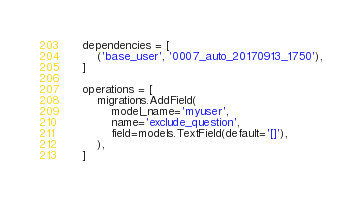<code> <loc_0><loc_0><loc_500><loc_500><_Python_>
    dependencies = [
        ('base_user', '0007_auto_20170913_1750'),
    ]

    operations = [
        migrations.AddField(
            model_name='myuser',
            name='exclude_question',
            field=models.TextField(default='[]'),
        ),
    ]
</code> 